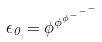Convert formula to latex. <formula><loc_0><loc_0><loc_500><loc_500>\epsilon _ { 0 } = \phi ^ { \phi ^ { \phi ^ { - ^ { - ^ { - } } } } }</formula> 